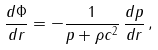<formula> <loc_0><loc_0><loc_500><loc_500>\frac { d \Phi } { d r } = - \frac { 1 } { p + \rho c ^ { 2 } } \, \frac { d p } { d r } \, ,</formula> 